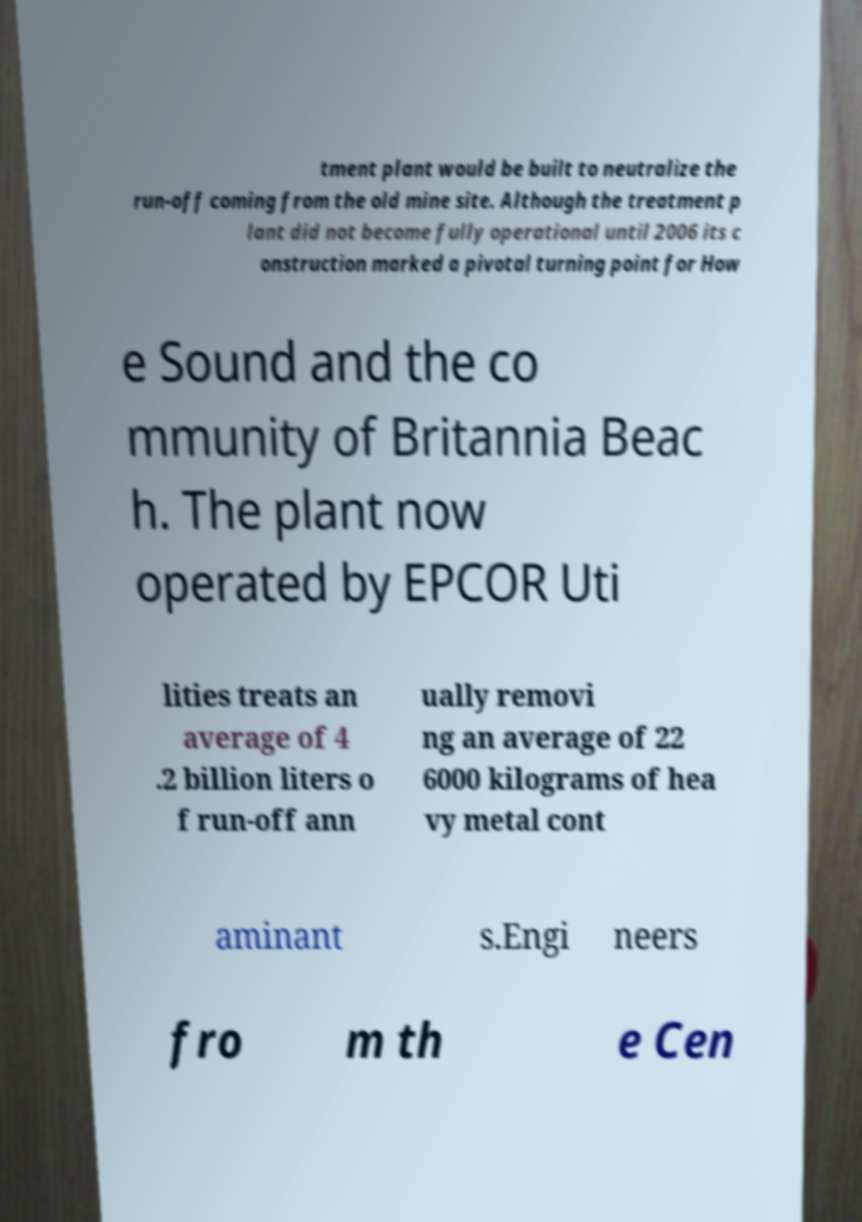There's text embedded in this image that I need extracted. Can you transcribe it verbatim? tment plant would be built to neutralize the run-off coming from the old mine site. Although the treatment p lant did not become fully operational until 2006 its c onstruction marked a pivotal turning point for How e Sound and the co mmunity of Britannia Beac h. The plant now operated by EPCOR Uti lities treats an average of 4 .2 billion liters o f run-off ann ually removi ng an average of 22 6000 kilograms of hea vy metal cont aminant s.Engi neers fro m th e Cen 